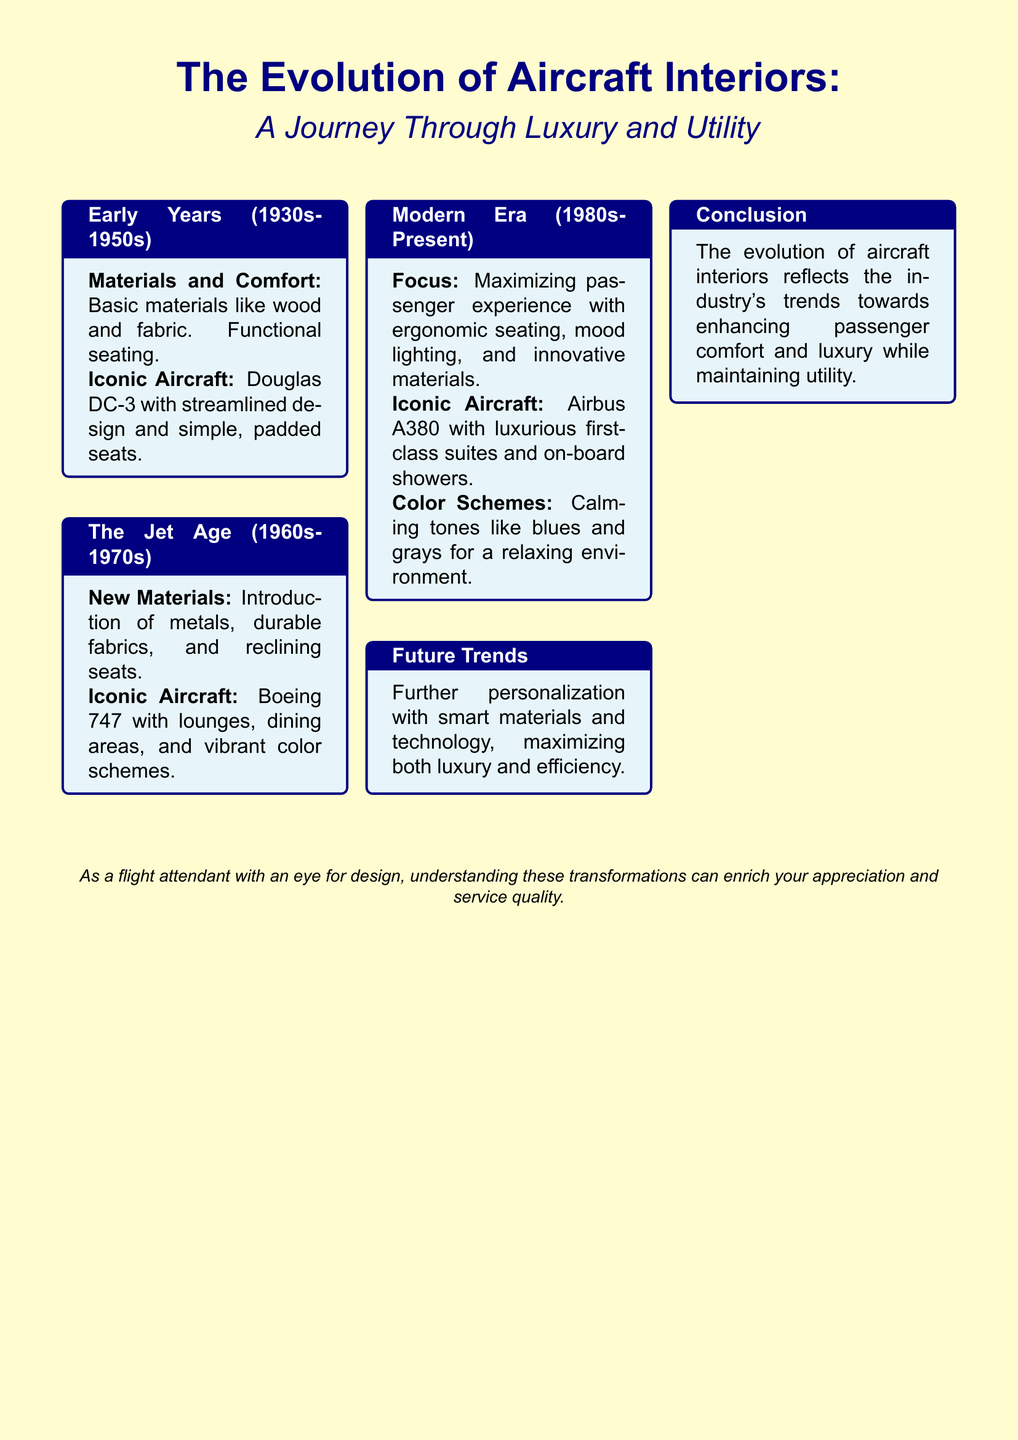What materials were used in the early years of aircraft interiors? The early years utilized basic materials like wood and fabric for comfort.
Answer: Wood and fabric Which iconic aircraft is associated with the Jet Age? The document mentions the Boeing 747 as an iconic aircraft of the Jet Age.
Answer: Boeing 747 What seating innovation was introduced during the Jet Age? The Jet Age introduced reclining seats for passenger comfort.
Answer: Reclining seats What is a key feature of modern aircraft interiors? Modern aircraft interiors focus on maximizing passenger experience with ergonomic seating.
Answer: Ergonomic seating What color schemes are preferred in the modern era for aircraft interiors? The document states that calming tones like blues and grays are used in modern aircraft interiors.
Answer: Blues and grays Which aircraft features luxurious first-class suites? The Airbus A380 is noted for having luxurious first-class suites.
Answer: Airbus A380 What trend is anticipated for the future of aircraft interiors? Future trends include further personalization with smart materials and technology.
Answer: Personalization What period marks the beginning of the evolution of aircraft interiors? The evolution began in the early years, specifically the 1930s.
Answer: 1930s What does the document suggest about the relationship between luxury and utility in aircraft interiors? The document concludes that the evolution reflects a trend towards enhancing passenger comfort and luxury while maintaining utility.
Answer: Comfort and luxury 